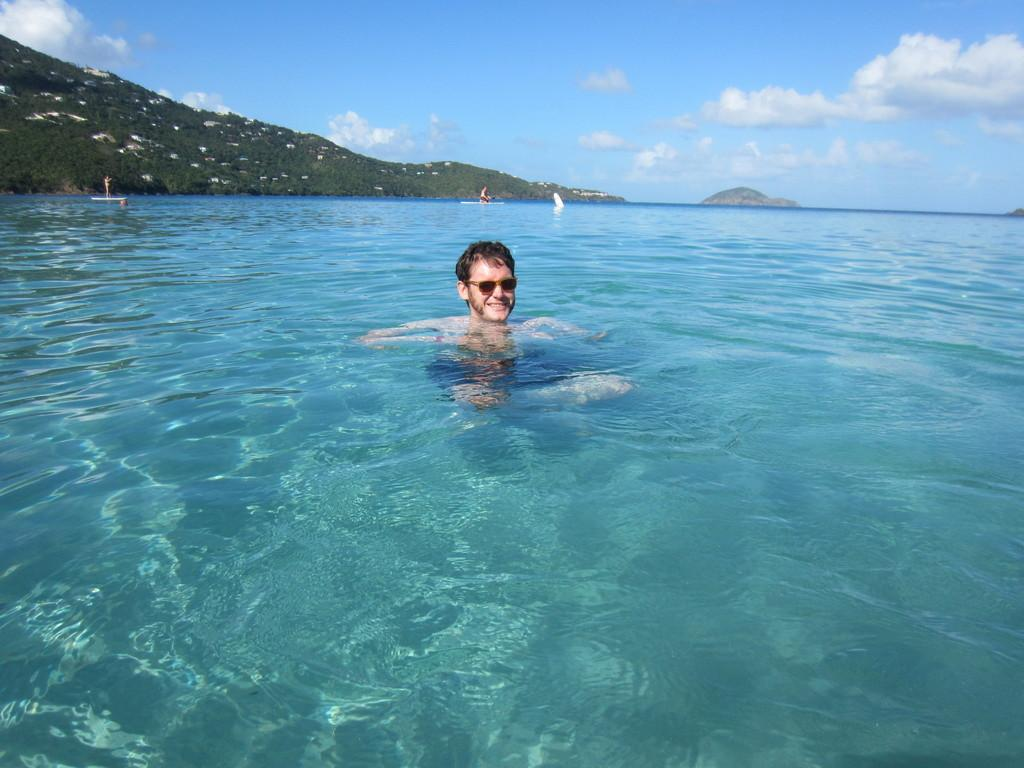What is the man in the image doing? There is a man in the water in the image. Can you see any other people in the image? Yes, there are people visible in the distance. What can be seen in the background of the image? There are hills, trees, and the sky visible in the background of the image. What is the condition of the sky in the image? The sky is visible in the background of the image, and clouds are present. What type of meal is the man eating in the image? There is no meal present in the image; the man is in the water. What kind of dress is the lawyer wearing in the image? There is no lawyer or dress present in the image. 